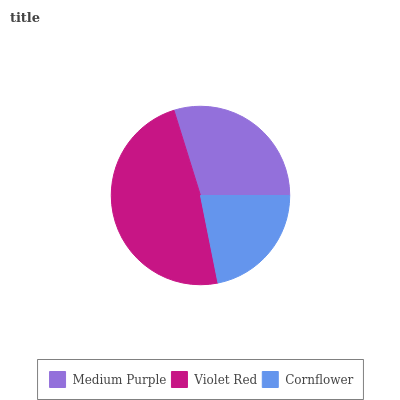Is Cornflower the minimum?
Answer yes or no. Yes. Is Violet Red the maximum?
Answer yes or no. Yes. Is Violet Red the minimum?
Answer yes or no. No. Is Cornflower the maximum?
Answer yes or no. No. Is Violet Red greater than Cornflower?
Answer yes or no. Yes. Is Cornflower less than Violet Red?
Answer yes or no. Yes. Is Cornflower greater than Violet Red?
Answer yes or no. No. Is Violet Red less than Cornflower?
Answer yes or no. No. Is Medium Purple the high median?
Answer yes or no. Yes. Is Medium Purple the low median?
Answer yes or no. Yes. Is Violet Red the high median?
Answer yes or no. No. Is Violet Red the low median?
Answer yes or no. No. 